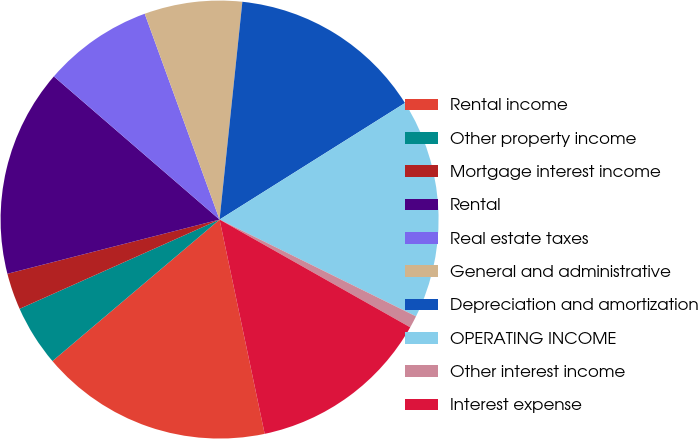Convert chart. <chart><loc_0><loc_0><loc_500><loc_500><pie_chart><fcel>Rental income<fcel>Other property income<fcel>Mortgage interest income<fcel>Rental<fcel>Real estate taxes<fcel>General and administrative<fcel>Depreciation and amortization<fcel>OPERATING INCOME<fcel>Other interest income<fcel>Interest expense<nl><fcel>17.12%<fcel>4.5%<fcel>2.7%<fcel>15.32%<fcel>8.11%<fcel>7.21%<fcel>14.41%<fcel>16.22%<fcel>0.9%<fcel>13.51%<nl></chart> 